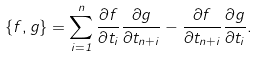Convert formula to latex. <formula><loc_0><loc_0><loc_500><loc_500>\{ f , g \} = \sum ^ { n } _ { i = 1 } \frac { \partial f } { \partial t _ { i } } \frac { \partial g } { \partial t _ { n + i } } - \frac { \partial f } { \partial t _ { n + i } } \frac { \partial g } { \partial t _ { i } } .</formula> 